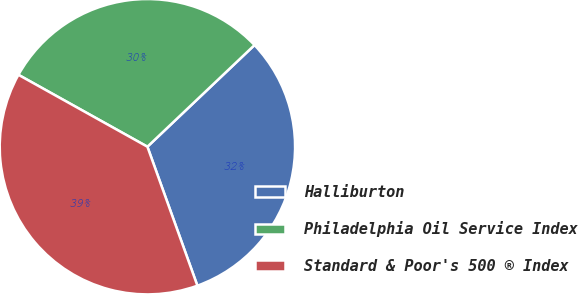Convert chart to OTSL. <chart><loc_0><loc_0><loc_500><loc_500><pie_chart><fcel>Halliburton<fcel>Philadelphia Oil Service Index<fcel>Standard & Poor's 500 ® Index<nl><fcel>31.59%<fcel>29.82%<fcel>38.59%<nl></chart> 